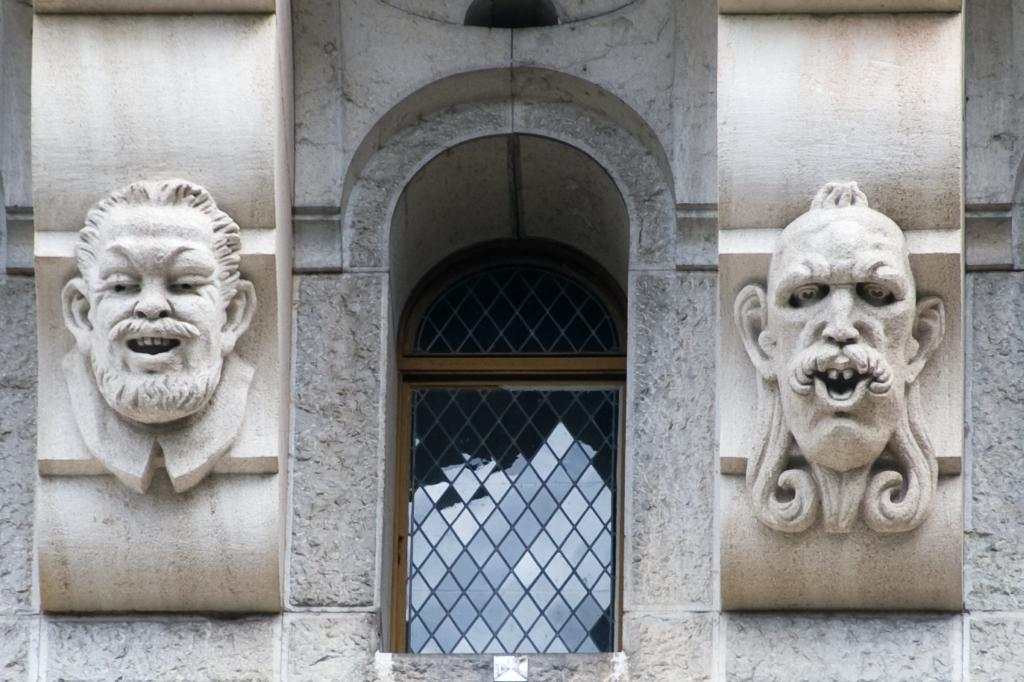What is the main structure visible in the image? There is a building in the image. What type of artwork is displayed on the building? The building has two paintings of architecture. Where is the window located in the image? There is a window in the middle of the image. What material is used for the window? The window has glass. How many birds can be seen sitting on the branch in the image? There are no birds or branches present in the image. What type of goose is depicted in the painting on the building? There is no goose depicted in the painting on the building; the paintings are of architecture. 